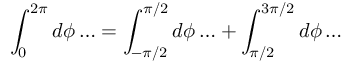<formula> <loc_0><loc_0><loc_500><loc_500>\int _ { 0 } ^ { 2 \pi } d \phi \dots = \int _ { - \pi / 2 } ^ { \pi / 2 } d \phi \dots + \int _ { \pi / 2 } ^ { 3 \pi / 2 } d \phi \dots</formula> 